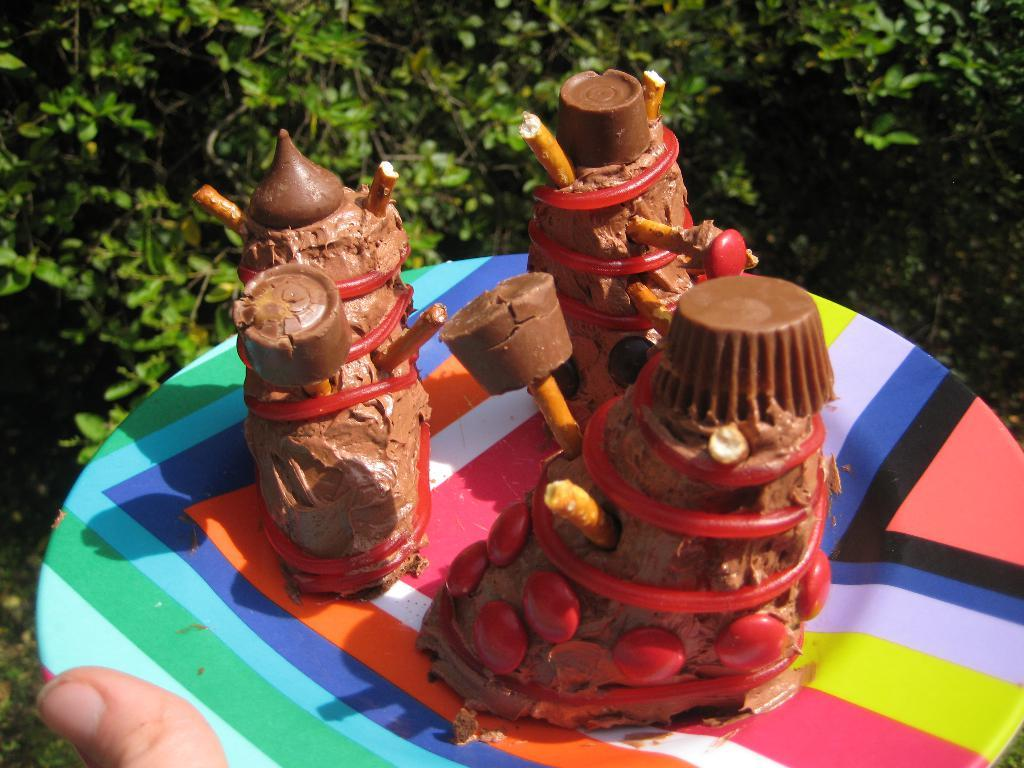What part of the human body is visible in the image? There is a person's finger in the image. What object is present near the finger? There is a plate in the image. What is on the plate? There are objects in the plate. What can be seen in the background of the image? There are plants in the background of the image. What type of silk is being used to create the system in the image? There is no silk or system present in the image. 